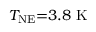Convert formula to latex. <formula><loc_0><loc_0><loc_500><loc_500>T _ { N E } { = } 3 . 8 \ K</formula> 